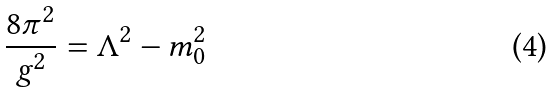Convert formula to latex. <formula><loc_0><loc_0><loc_500><loc_500>\frac { 8 \pi ^ { 2 } } { g ^ { 2 } } = \Lambda ^ { 2 } - m _ { 0 } ^ { 2 }</formula> 